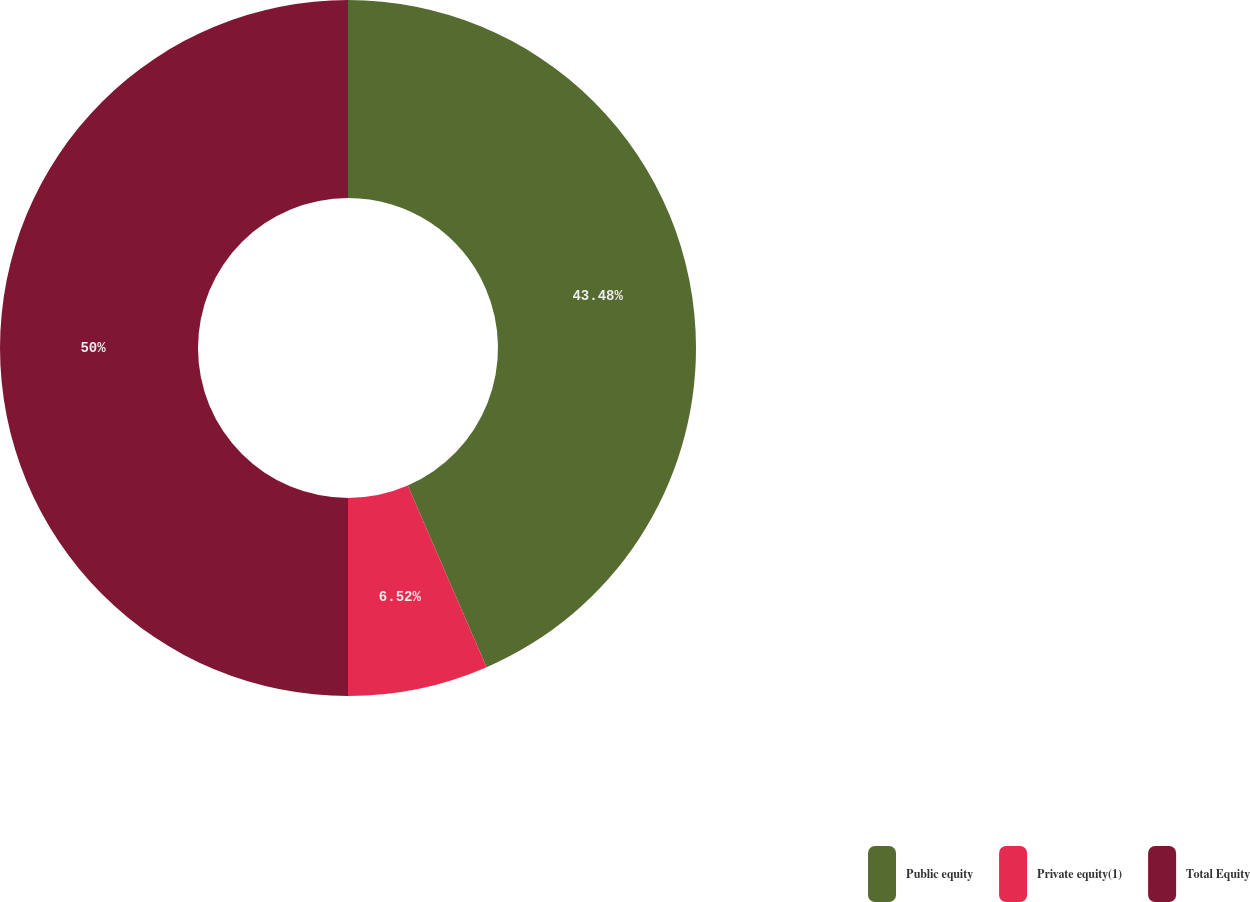Convert chart. <chart><loc_0><loc_0><loc_500><loc_500><pie_chart><fcel>Public equity<fcel>Private equity(1)<fcel>Total Equity<nl><fcel>43.48%<fcel>6.52%<fcel>50.0%<nl></chart> 